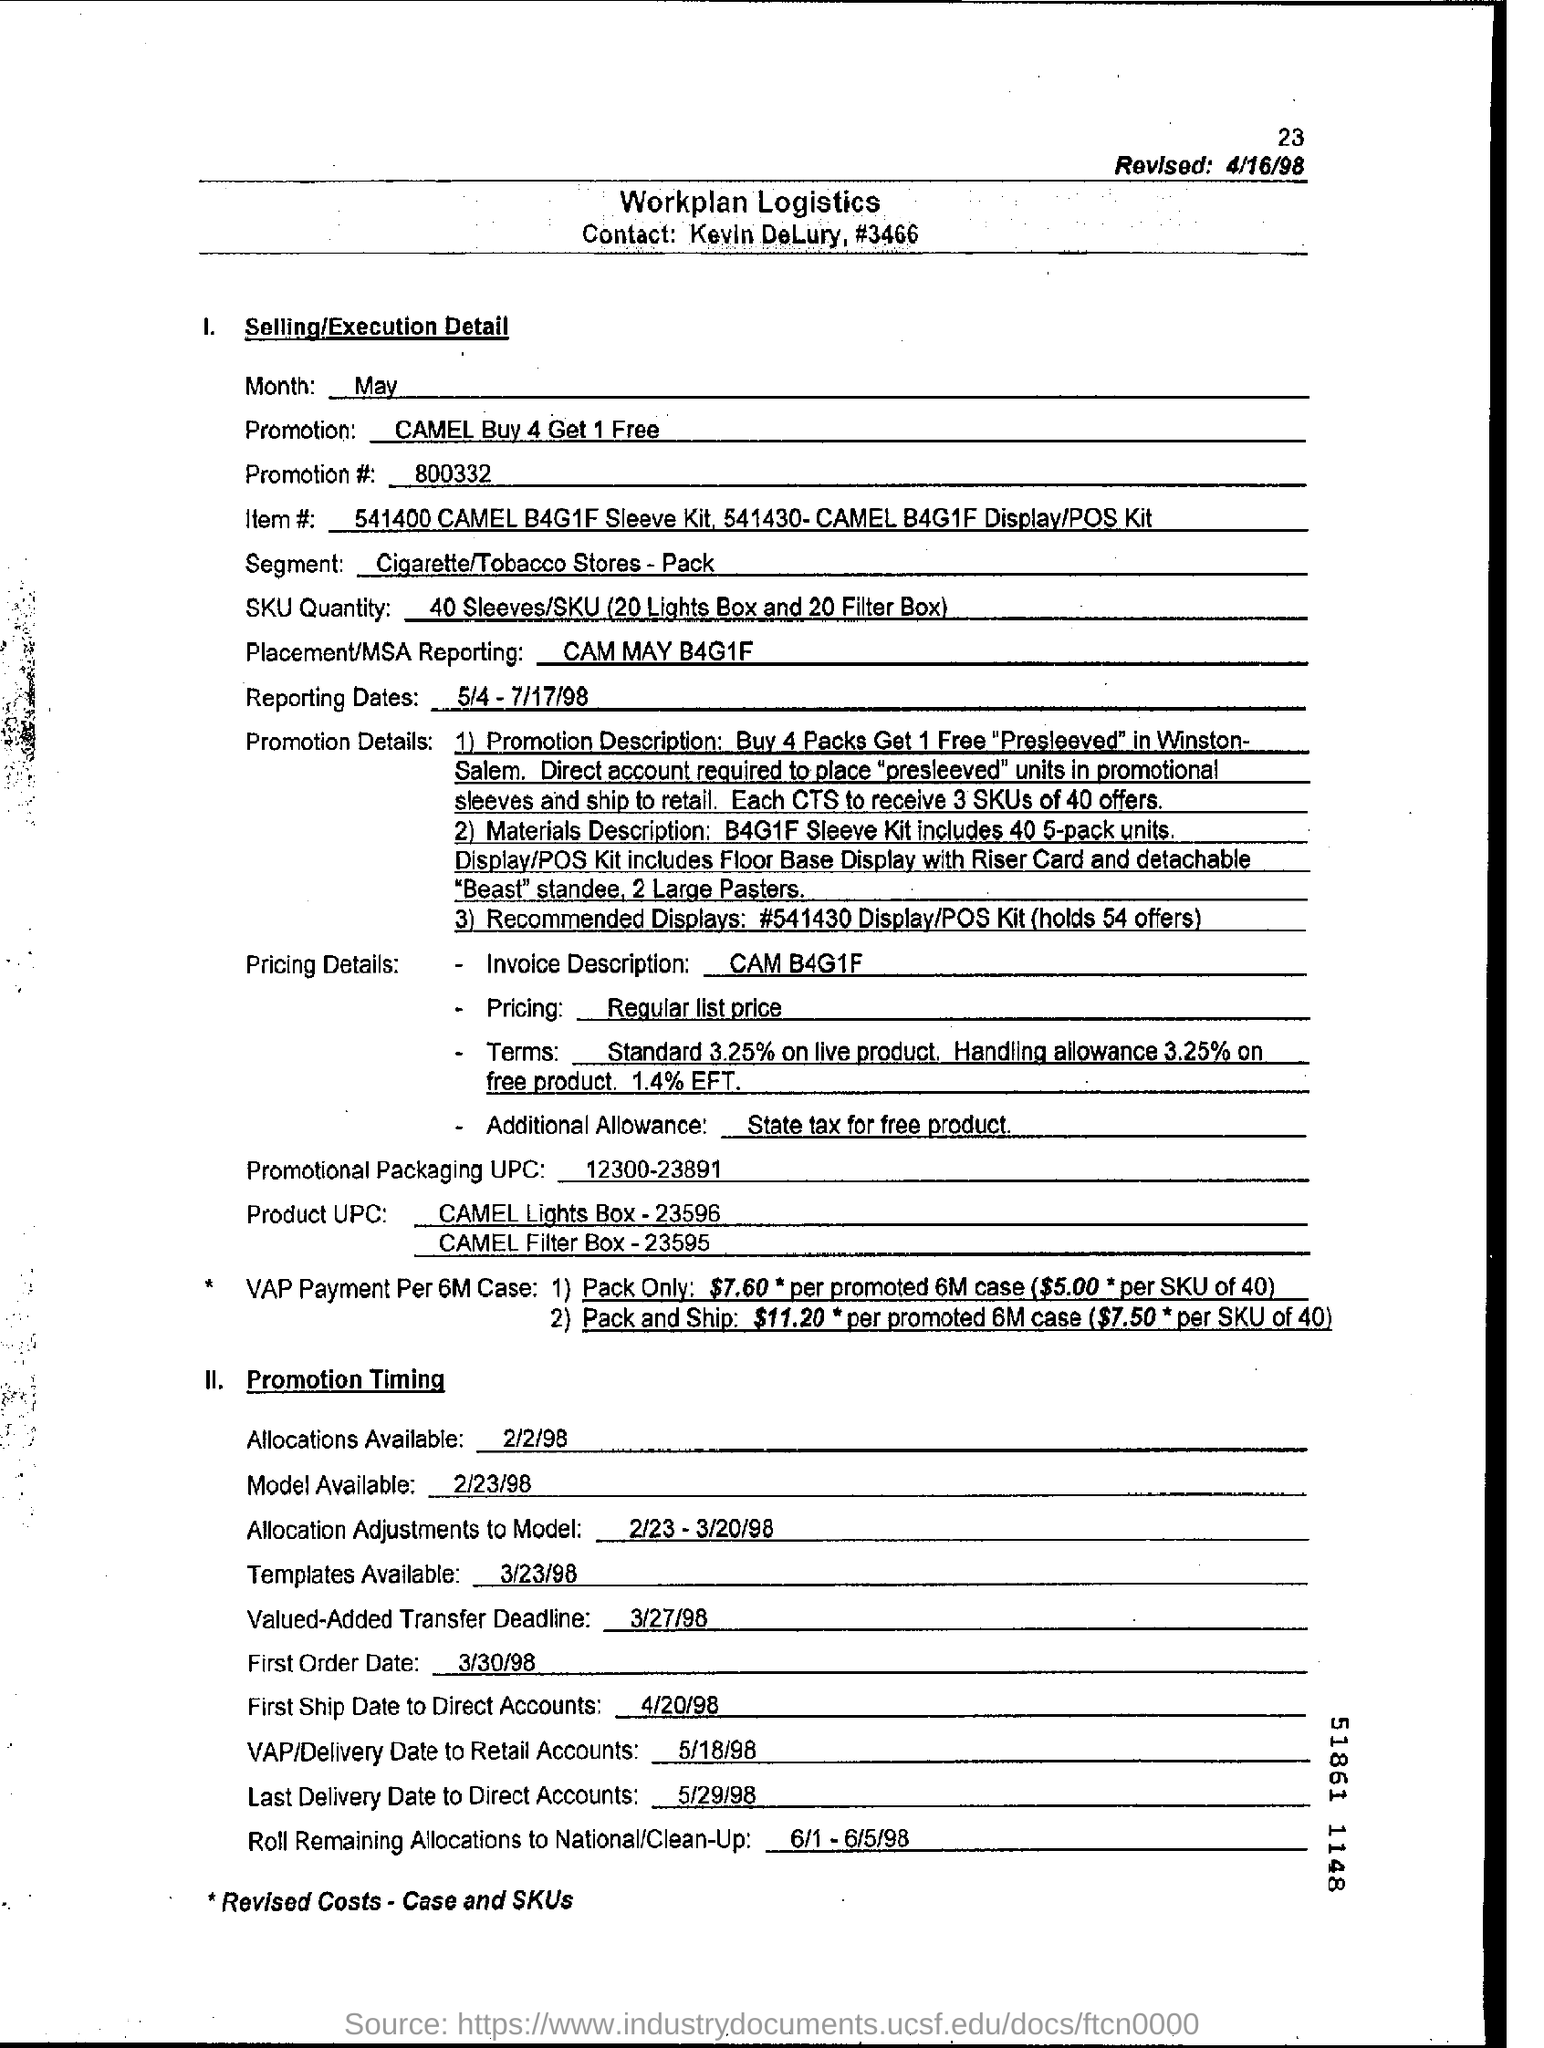What are the dates for the promotion timing according to this document? The promotion timing as stated in the document includes various key dates. Allocation adjustments to the model range from February 23 to March 20, 1998, with different deadlines and distribution dates through to early June 1998. 